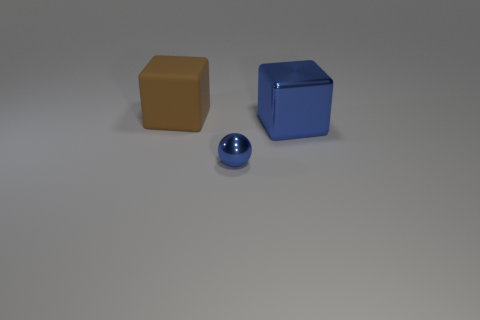Is the size of the matte cube the same as the block on the right side of the small shiny ball?
Make the answer very short. Yes. There is a cube that is on the right side of the brown matte object; is its size the same as the rubber object?
Offer a very short reply. Yes. How many other things are the same material as the big blue object?
Ensure brevity in your answer.  1. Is the number of shiny balls that are in front of the blue sphere the same as the number of big blue objects that are in front of the big blue cube?
Your answer should be very brief. Yes. What color is the thing that is behind the large thing to the right of the block behind the large blue thing?
Offer a very short reply. Brown. There is a blue metallic thing that is left of the large blue metal object; what is its shape?
Offer a terse response. Sphere. What shape is the blue object that is the same material as the small ball?
Give a very brief answer. Cube. Is there anything else that has the same shape as the small object?
Ensure brevity in your answer.  No. There is a large metal cube; what number of blue metallic balls are right of it?
Give a very brief answer. 0. Are there the same number of blue blocks that are on the left side of the big shiny object and large purple shiny cylinders?
Give a very brief answer. Yes. 